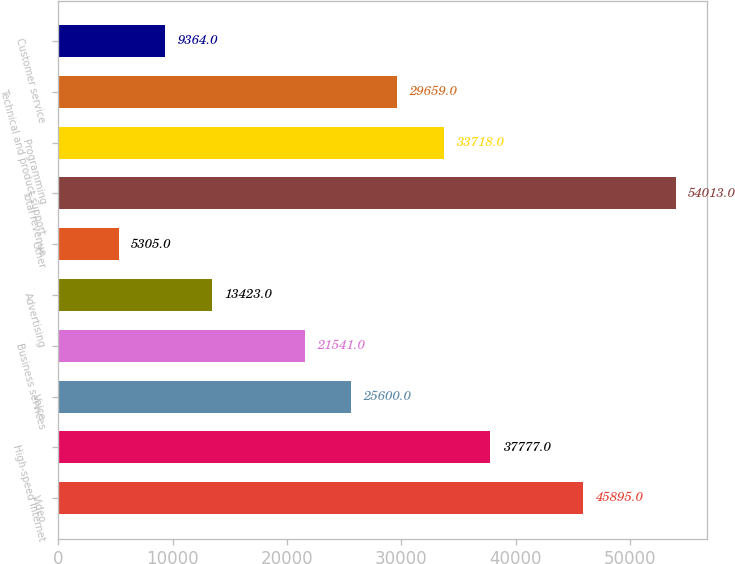Convert chart to OTSL. <chart><loc_0><loc_0><loc_500><loc_500><bar_chart><fcel>Video<fcel>High-speed Internet<fcel>Voice<fcel>Business services<fcel>Advertising<fcel>Other<fcel>Total revenue<fcel>Programming<fcel>Technical and product support<fcel>Customer service<nl><fcel>45895<fcel>37777<fcel>25600<fcel>21541<fcel>13423<fcel>5305<fcel>54013<fcel>33718<fcel>29659<fcel>9364<nl></chart> 